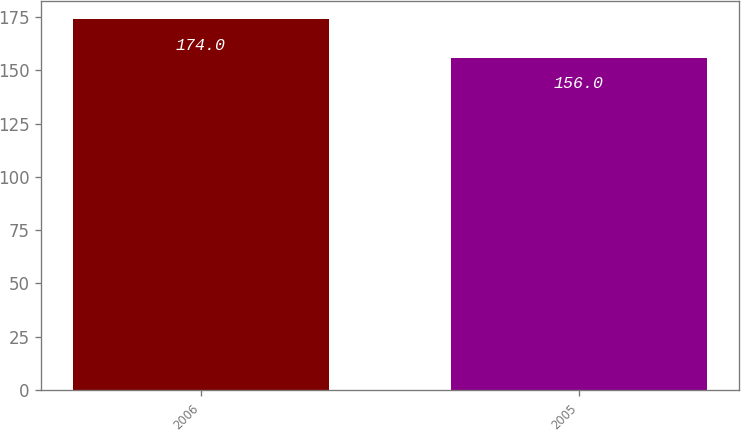<chart> <loc_0><loc_0><loc_500><loc_500><bar_chart><fcel>2006<fcel>2005<nl><fcel>174<fcel>156<nl></chart> 